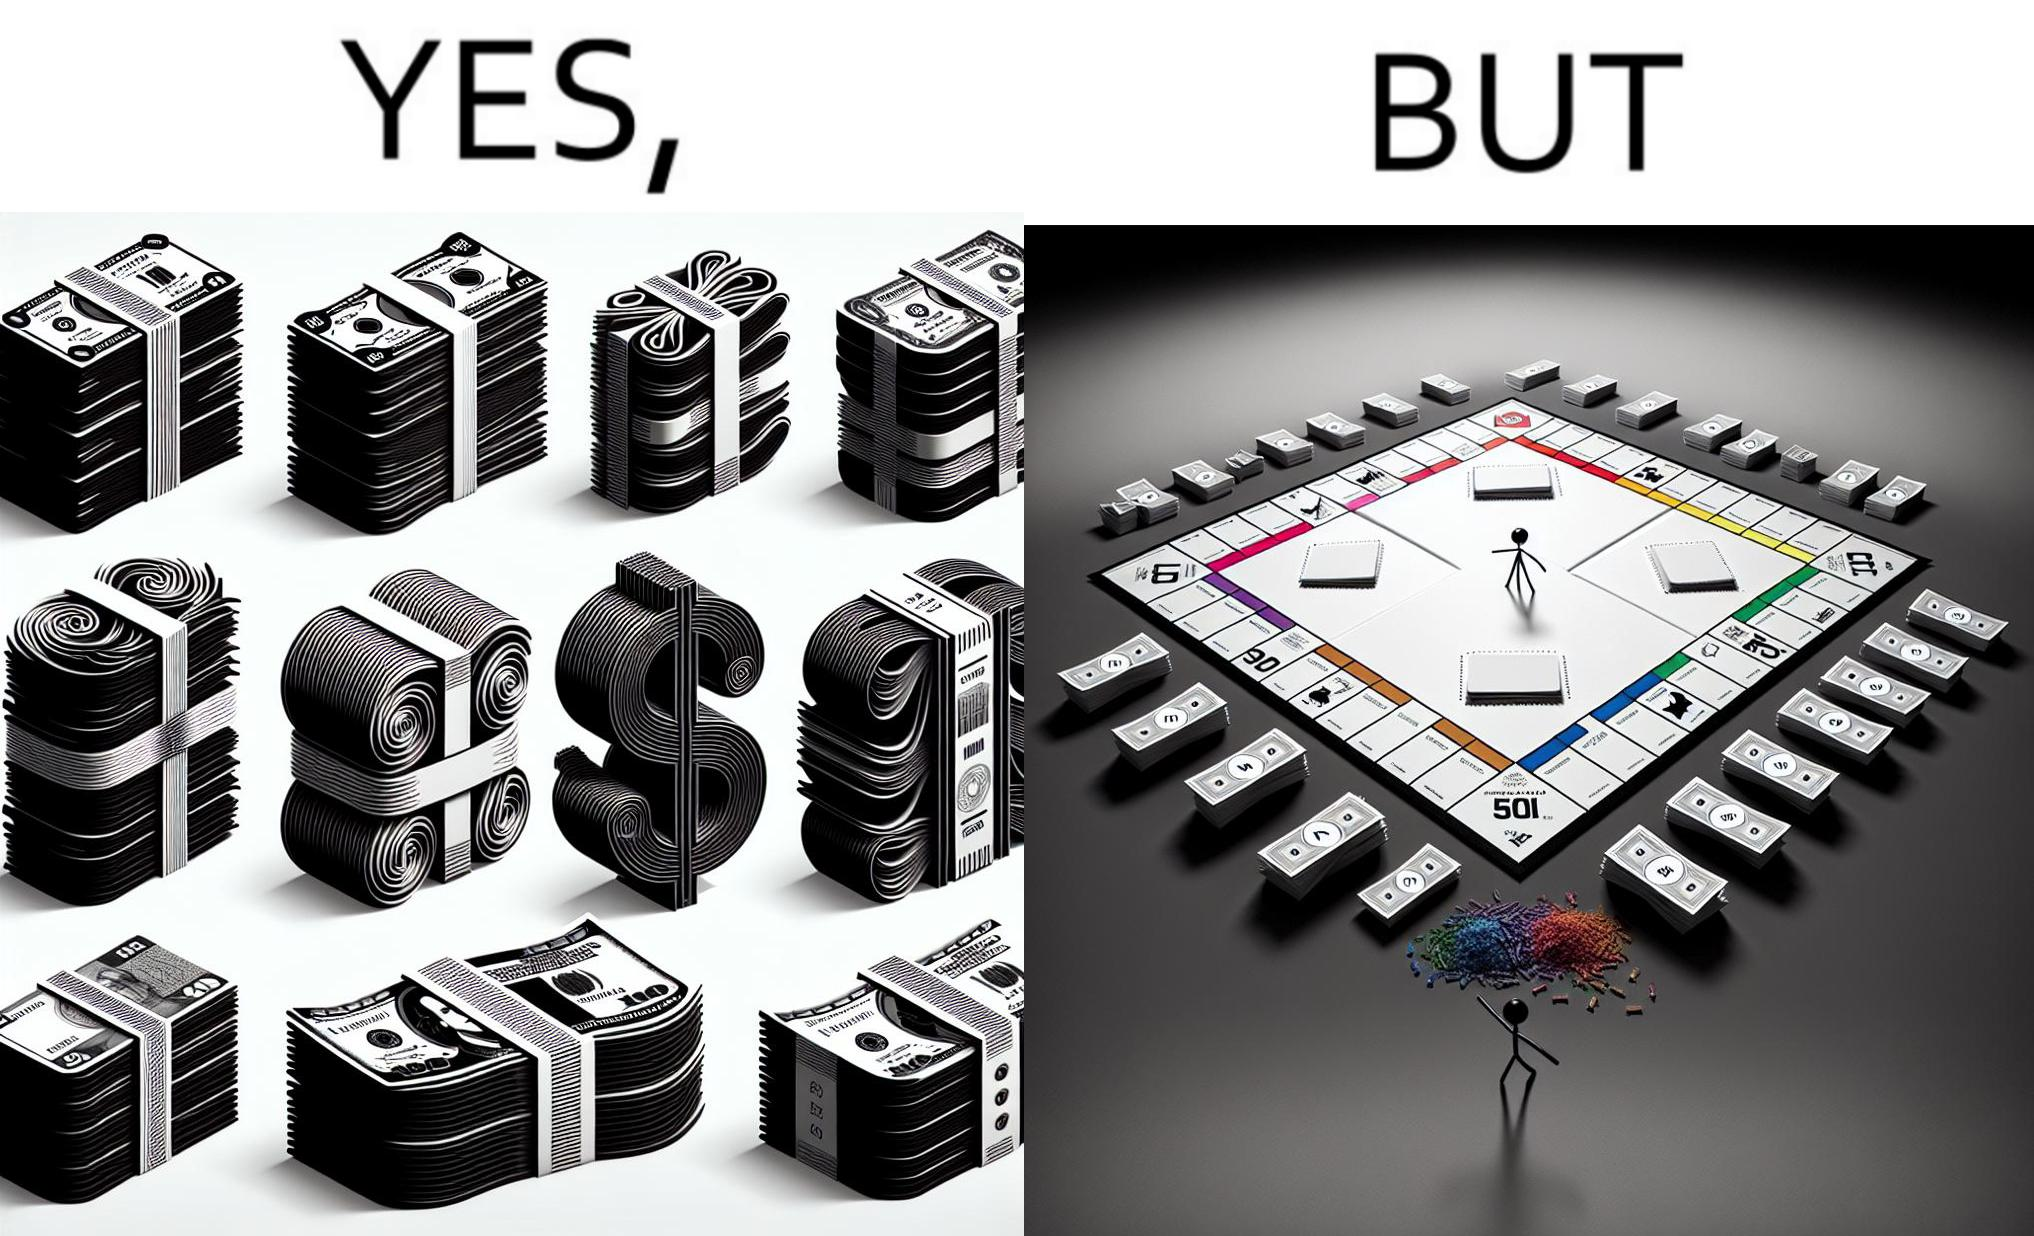Describe what you see in the left and right parts of this image. In the left part of the image: many different color currency notes' bundles In the right part of the image: a board of game monopoly with many different color currency notes' bundles 